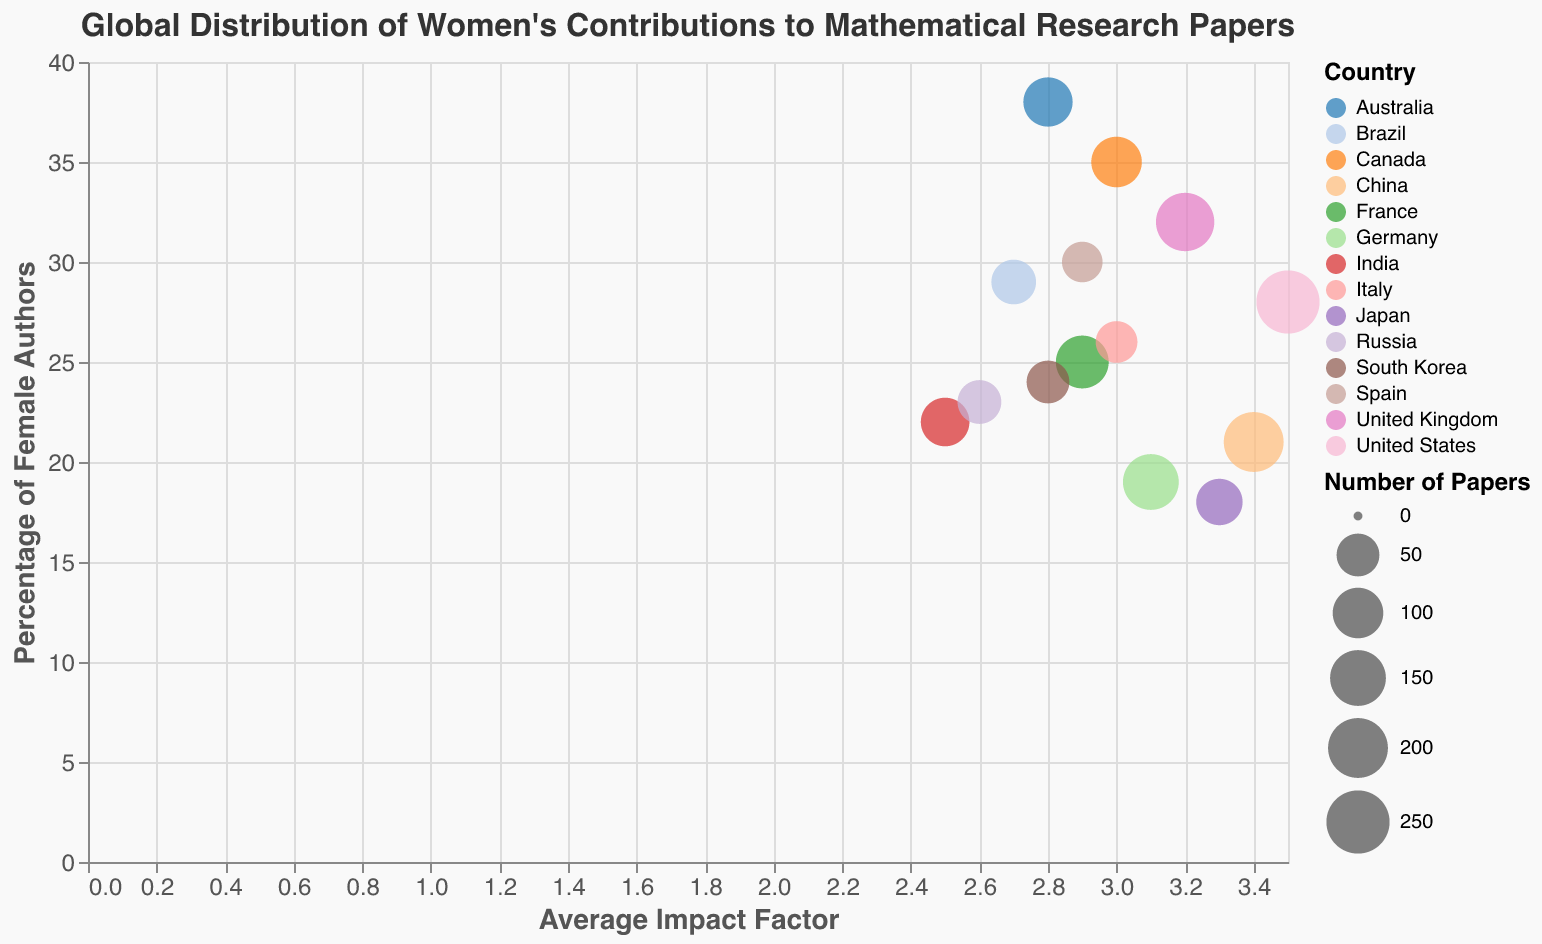What's the title of the chart? The title of the chart is displayed at the top of the figure and reads, "Global Distribution of Women's Contributions to Mathematical Research Papers."
Answer: Global Distribution of Women's Contributions to Mathematical Research Papers Which country has the highest average impact factor? By looking at the x-axis titled "Average Impact Factor" and identifying the bubble that is furthest to the right, we see that the United States has the highest average impact factor of 3.5.
Answer: United States How many countries have a percentage of female authors greater than 30%? We look along the y-axis labeled "Percentage of Female Authors" for values greater than 30%. The countries corresponding to these points are the United Kingdom, Canada, Australia, and Spain. Thus, there are 4 countries.
Answer: 4 Which country has the largest number of papers? We observe the size of the bubbles, which represent the number of papers. The largest bubble corresponds to the United States.
Answer: United States What is the average impact factor for Brazil? Hovering over or locating Brazil's bubble on the chart, we see that the tooltip or data point shows an average impact factor of 2.7.
Answer: 2.7 Which country has the lowest percentage of female authors? By following the y-axis labeled "Percentage of Female Authors" to find the lowest point, we see this corresponds to Japan, which has a percentage of 18%.
Answer: Japan Compare the number of papers between the United States and China. Which country has more papers? Observing the bubble sizes for both countries as well as the provided data, the United States has 250 papers, while China has 200 papers. The United States has more papers.
Answer: United States What is the relationship between the percentage of female authors and the average impact factor in Australia? Finding Australia in the tooltip or on the chart, we see that Australia has a percentage of 38% female authors and an average impact factor of 2.8.
Answer: 38% female authors, 2.8 average impact factor Which country has a higher average impact factor: Italy or Germany? Checking the chart or the data, Italy has an average impact factor of 3.0, while Germany has 3.1. Therefore, Germany has a higher average impact factor.
Answer: Germany 